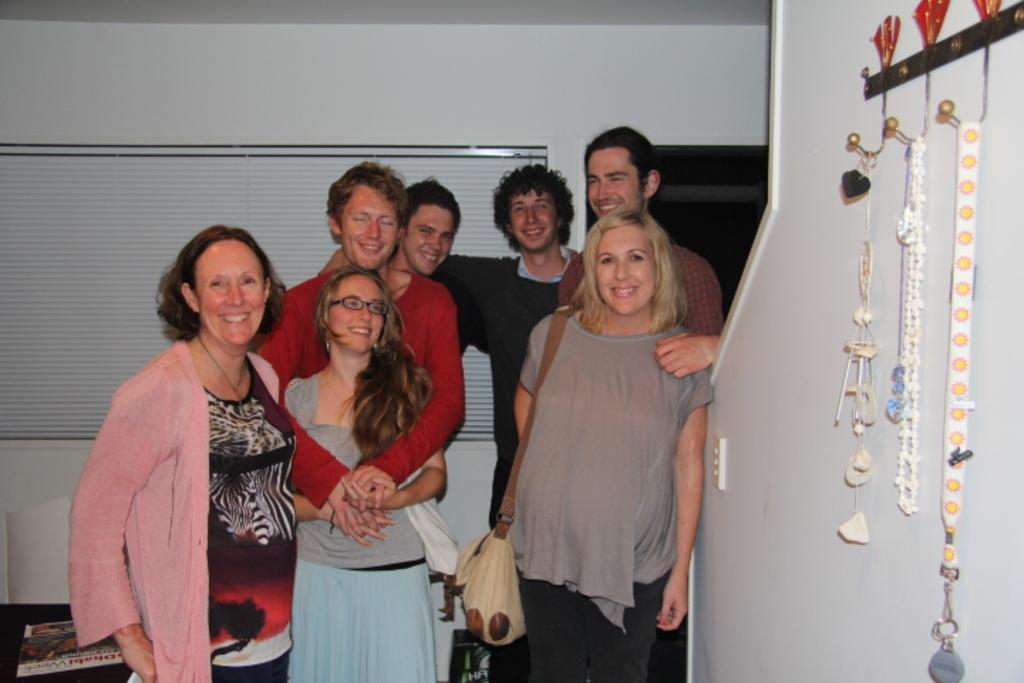Please provide a concise description of this image. In this picture we can see a few people standing and smiling. We can see a woman wearing a bag. There are a few decorative items on the stand on the right side. We can see a magazine on a black surface. There is a window blind and a wall in the background. 